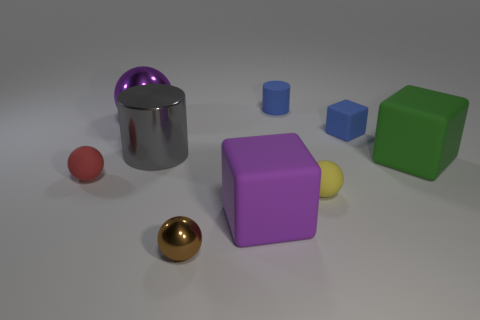Does the blue cylinder have the same material as the purple ball?
Your answer should be compact. No. What is the material of the tiny ball that is both to the left of the blue cylinder and behind the purple rubber thing?
Keep it short and to the point. Rubber. What shape is the brown thing that is made of the same material as the purple ball?
Your answer should be very brief. Sphere. There is a thing that is in front of the large purple rubber block; how many purple shiny spheres are in front of it?
Your answer should be compact. 0. What number of things are in front of the large green cube and to the left of the yellow thing?
Your response must be concise. 3. How many other objects are the same material as the yellow thing?
Make the answer very short. 5. There is a cylinder behind the big purple object that is left of the brown metal sphere; what is its color?
Ensure brevity in your answer.  Blue. Does the cylinder that is right of the big purple rubber thing have the same color as the tiny rubber block?
Offer a terse response. Yes. Is the metallic cylinder the same size as the brown shiny thing?
Give a very brief answer. No. There is a brown metal thing that is the same size as the yellow matte object; what is its shape?
Your answer should be very brief. Sphere. 